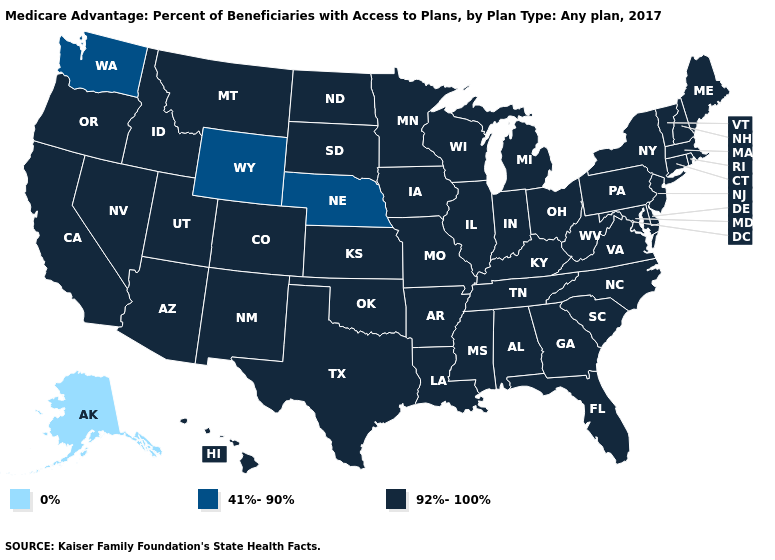Does Alaska have the lowest value in the USA?
Quick response, please. Yes. Name the states that have a value in the range 0%?
Answer briefly. Alaska. Name the states that have a value in the range 41%-90%?
Keep it brief. Nebraska, Washington, Wyoming. What is the lowest value in states that border Maryland?
Give a very brief answer. 92%-100%. Name the states that have a value in the range 41%-90%?
Quick response, please. Nebraska, Washington, Wyoming. What is the value of Wisconsin?
Concise answer only. 92%-100%. Among the states that border Colorado , which have the lowest value?
Answer briefly. Nebraska, Wyoming. Does West Virginia have the highest value in the USA?
Quick response, please. Yes. Does Maryland have a lower value than Vermont?
Answer briefly. No. Does Oregon have the same value as Washington?
Write a very short answer. No. What is the value of Wyoming?
Concise answer only. 41%-90%. Name the states that have a value in the range 41%-90%?
Quick response, please. Nebraska, Washington, Wyoming. How many symbols are there in the legend?
Be succinct. 3. 